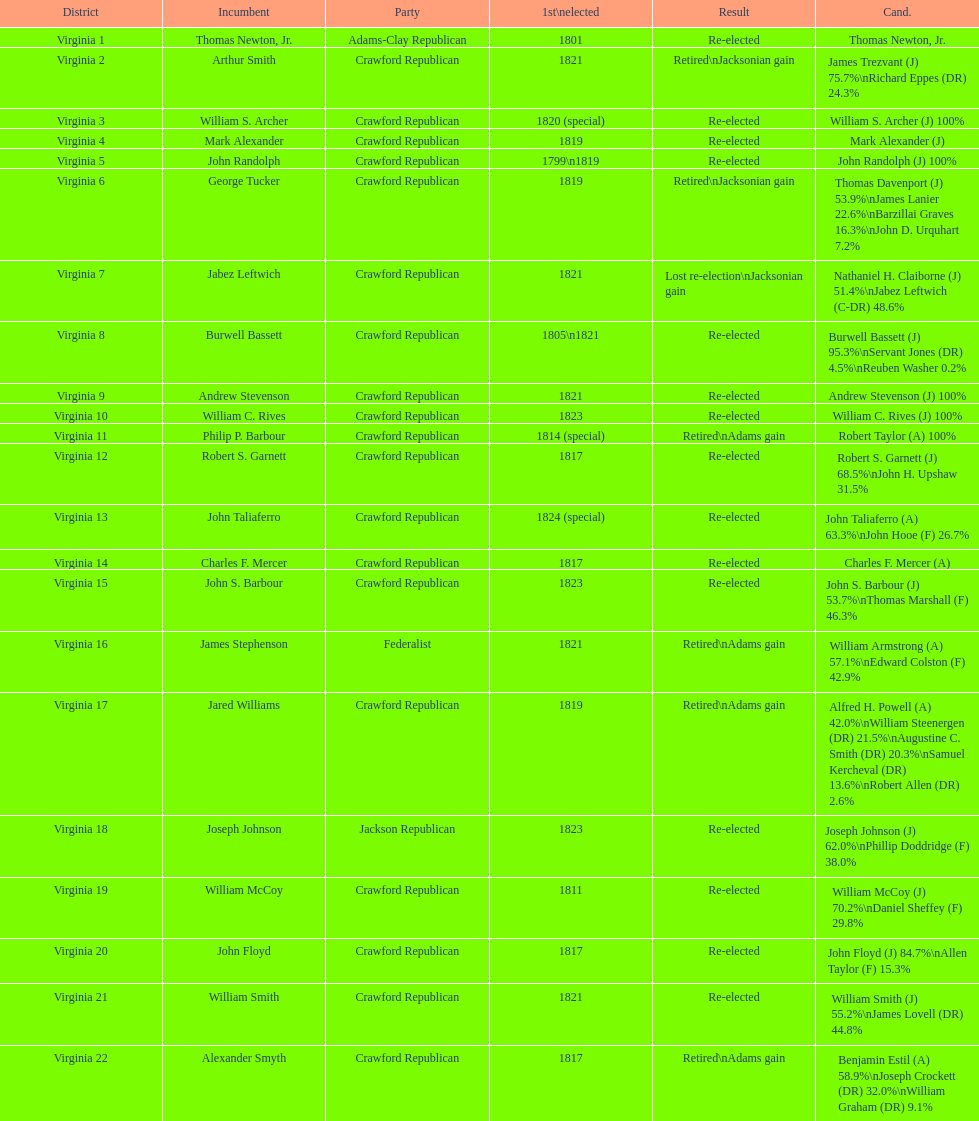Which jacksonian candidates got at least 76% of the vote in their races? Arthur Smith. Would you mind parsing the complete table? {'header': ['District', 'Incumbent', 'Party', '1st\\nelected', 'Result', 'Cand.'], 'rows': [['Virginia 1', 'Thomas Newton, Jr.', 'Adams-Clay Republican', '1801', 'Re-elected', 'Thomas Newton, Jr.'], ['Virginia 2', 'Arthur Smith', 'Crawford Republican', '1821', 'Retired\\nJacksonian gain', 'James Trezvant (J) 75.7%\\nRichard Eppes (DR) 24.3%'], ['Virginia 3', 'William S. Archer', 'Crawford Republican', '1820 (special)', 'Re-elected', 'William S. Archer (J) 100%'], ['Virginia 4', 'Mark Alexander', 'Crawford Republican', '1819', 'Re-elected', 'Mark Alexander (J)'], ['Virginia 5', 'John Randolph', 'Crawford Republican', '1799\\n1819', 'Re-elected', 'John Randolph (J) 100%'], ['Virginia 6', 'George Tucker', 'Crawford Republican', '1819', 'Retired\\nJacksonian gain', 'Thomas Davenport (J) 53.9%\\nJames Lanier 22.6%\\nBarzillai Graves 16.3%\\nJohn D. Urquhart 7.2%'], ['Virginia 7', 'Jabez Leftwich', 'Crawford Republican', '1821', 'Lost re-election\\nJacksonian gain', 'Nathaniel H. Claiborne (J) 51.4%\\nJabez Leftwich (C-DR) 48.6%'], ['Virginia 8', 'Burwell Bassett', 'Crawford Republican', '1805\\n1821', 'Re-elected', 'Burwell Bassett (J) 95.3%\\nServant Jones (DR) 4.5%\\nReuben Washer 0.2%'], ['Virginia 9', 'Andrew Stevenson', 'Crawford Republican', '1821', 'Re-elected', 'Andrew Stevenson (J) 100%'], ['Virginia 10', 'William C. Rives', 'Crawford Republican', '1823', 'Re-elected', 'William C. Rives (J) 100%'], ['Virginia 11', 'Philip P. Barbour', 'Crawford Republican', '1814 (special)', 'Retired\\nAdams gain', 'Robert Taylor (A) 100%'], ['Virginia 12', 'Robert S. Garnett', 'Crawford Republican', '1817', 'Re-elected', 'Robert S. Garnett (J) 68.5%\\nJohn H. Upshaw 31.5%'], ['Virginia 13', 'John Taliaferro', 'Crawford Republican', '1824 (special)', 'Re-elected', 'John Taliaferro (A) 63.3%\\nJohn Hooe (F) 26.7%'], ['Virginia 14', 'Charles F. Mercer', 'Crawford Republican', '1817', 'Re-elected', 'Charles F. Mercer (A)'], ['Virginia 15', 'John S. Barbour', 'Crawford Republican', '1823', 'Re-elected', 'John S. Barbour (J) 53.7%\\nThomas Marshall (F) 46.3%'], ['Virginia 16', 'James Stephenson', 'Federalist', '1821', 'Retired\\nAdams gain', 'William Armstrong (A) 57.1%\\nEdward Colston (F) 42.9%'], ['Virginia 17', 'Jared Williams', 'Crawford Republican', '1819', 'Retired\\nAdams gain', 'Alfred H. Powell (A) 42.0%\\nWilliam Steenergen (DR) 21.5%\\nAugustine C. Smith (DR) 20.3%\\nSamuel Kercheval (DR) 13.6%\\nRobert Allen (DR) 2.6%'], ['Virginia 18', 'Joseph Johnson', 'Jackson Republican', '1823', 'Re-elected', 'Joseph Johnson (J) 62.0%\\nPhillip Doddridge (F) 38.0%'], ['Virginia 19', 'William McCoy', 'Crawford Republican', '1811', 'Re-elected', 'William McCoy (J) 70.2%\\nDaniel Sheffey (F) 29.8%'], ['Virginia 20', 'John Floyd', 'Crawford Republican', '1817', 'Re-elected', 'John Floyd (J) 84.7%\\nAllen Taylor (F) 15.3%'], ['Virginia 21', 'William Smith', 'Crawford Republican', '1821', 'Re-elected', 'William Smith (J) 55.2%\\nJames Lovell (DR) 44.8%'], ['Virginia 22', 'Alexander Smyth', 'Crawford Republican', '1817', 'Retired\\nAdams gain', 'Benjamin Estil (A) 58.9%\\nJoseph Crockett (DR) 32.0%\\nWilliam Graham (DR) 9.1%']]} 